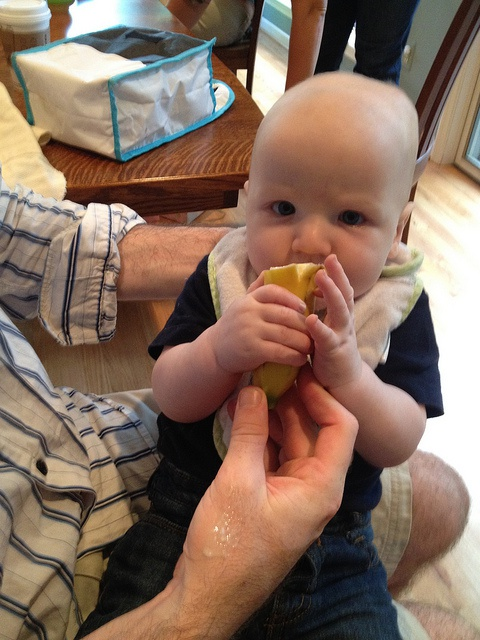Describe the objects in this image and their specific colors. I can see people in lightgray, gray, tan, and salmon tones, people in lightgray, brown, tan, black, and maroon tones, dining table in lightgray, maroon, ivory, darkgray, and black tones, chair in lightgray, maroon, brown, gray, and black tones, and people in lightgray, black, gray, navy, and darkgray tones in this image. 